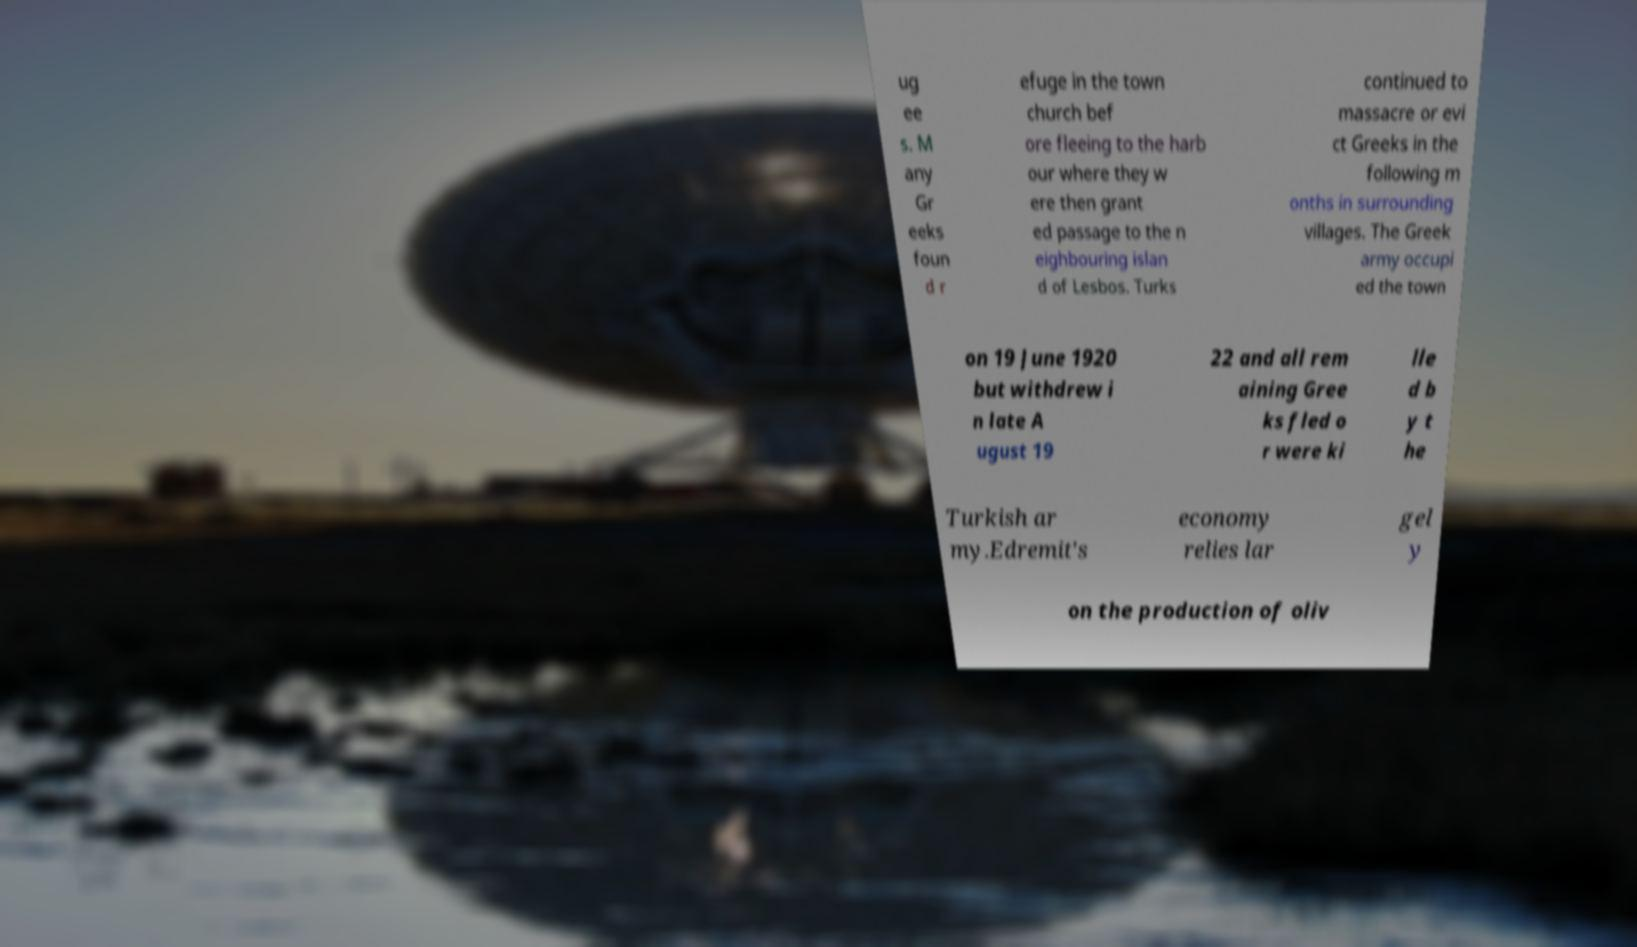Can you accurately transcribe the text from the provided image for me? ug ee s. M any Gr eeks foun d r efuge in the town church bef ore fleeing to the harb our where they w ere then grant ed passage to the n eighbouring islan d of Lesbos. Turks continued to massacre or evi ct Greeks in the following m onths in surrounding villages. The Greek army occupi ed the town on 19 June 1920 but withdrew i n late A ugust 19 22 and all rem aining Gree ks fled o r were ki lle d b y t he Turkish ar my.Edremit's economy relies lar gel y on the production of oliv 